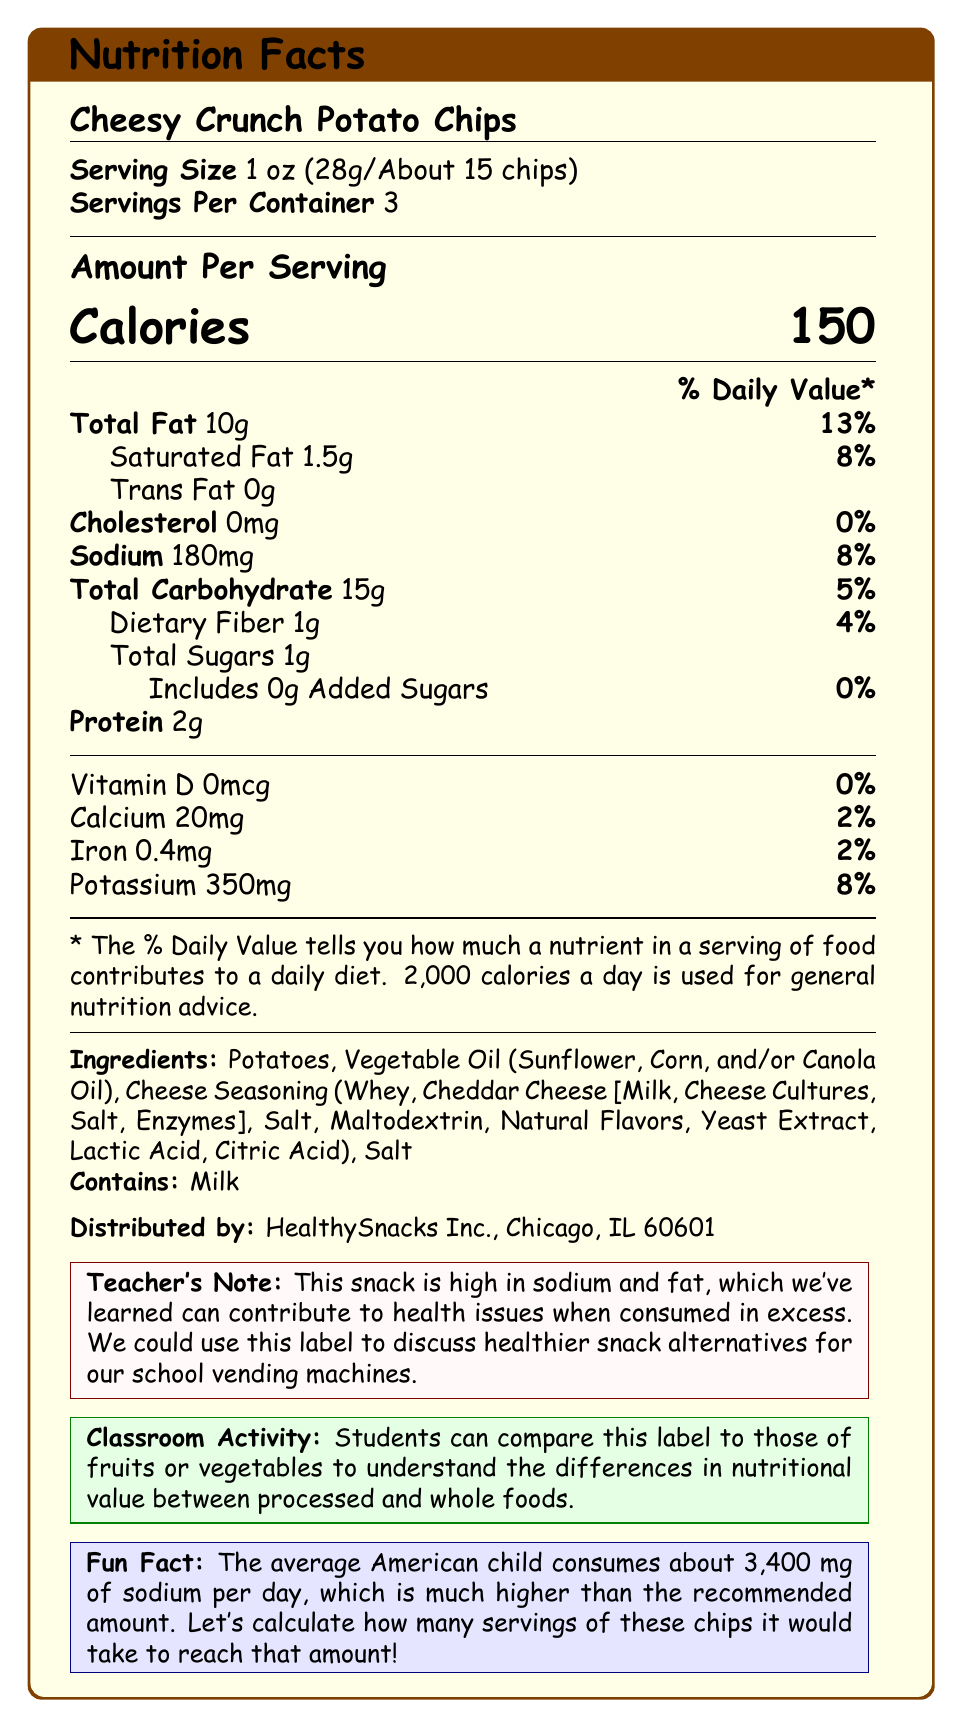what is the product name? The product name "Cheesy Crunch Potato Chips" is prominently displayed at the top of the document.
Answer: Cheesy Crunch Potato Chips what is the serving size? The serving size is listed right below the product name, specifying 1 oz (28g/About 15 chips).
Answer: 1 oz (28g/About 15 chips) how many servings are in each container? The document states that there are 3 servings per container.
Answer: 3 how many grams of total fat are in one serving? The document shows "Total Fat 10g" under the Amount Per Serving section.
Answer: 10g what is the ingredient that contains an allergen? The allergen information mentions that the product contains milk, which is part of the Cheese Seasoning.
Answer: Cheese Seasoning list the major nutrients' daily value percentages and specify the highest one. The highest daily value percentage is for Total Fat, which is 13%.
Answer: Total Fat 13%, Saturated Fat 8%, Sodium 8%, Total Carbohydrate 5%, Dietary Fiber 4%, Calcium 2%, Iron 2%, Potassium 8% how many calories are there per serving? The document indicates that there are 150 calories per serving.
Answer: 150 what is the activity suggested for students in the classroom? The Classroom Activity box suggests that students compare this label to those of fruits or vegetables.
Answer: Compare this label to those of fruits or vegetables how many grams of dietary fiber are in one serving? A. 0g B. 0.5g C. 1g D. 1.5g The Dietary Fiber amount listed is 1g per serving.
Answer: C what is the sodium content of one serving? A. 150mg B. 180mg C. 200mg The document states that there are 180mg of sodium per serving.
Answer: B is this snack low in cholesterol? (Yes/No) The cholesterol content is listed as 0mg, which means it is low in cholesterol.
Answer: Yes can you tell the exact date the product was manufactured from the document? The document doesn't provide any information about the date of manufacture.
Answer: Not enough information summarize the main nutritional information on the document. The main nutritional information includes details about serving sizes, calories per serving, amounts of total fat, saturated fat, trans fat, cholesterol, sodium, carbohydrates, dietary fiber, sugars, protein, Vitamin D, calcium, iron, and potassium. Additional context is provided through a Teacher's Note, Classroom Activity, and Fun Fact section.
Answer: This document provides the nutritional information for Cheesy Crunch Potato Chips, highlighting serving size, calories, fat content, sodium, carbohydrates, fiber, protein, and vitamins/minerals. 